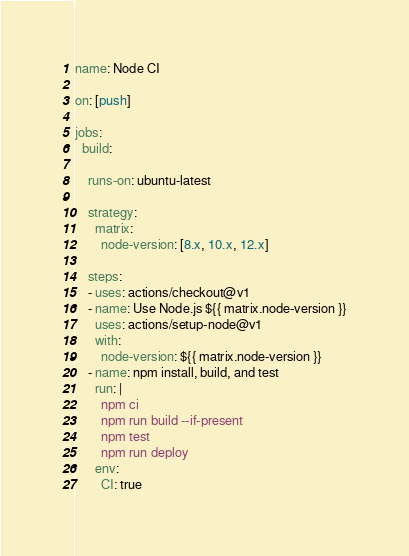<code> <loc_0><loc_0><loc_500><loc_500><_YAML_>name: Node CI

on: [push]

jobs:
  build:

    runs-on: ubuntu-latest

    strategy:
      matrix:
        node-version: [8.x, 10.x, 12.x]

    steps:
    - uses: actions/checkout@v1
    - name: Use Node.js ${{ matrix.node-version }}
      uses: actions/setup-node@v1
      with:
        node-version: ${{ matrix.node-version }}
    - name: npm install, build, and test
      run: |
        npm ci
        npm run build --if-present
        npm test
        npm run deploy
      env:
        CI: true
</code> 